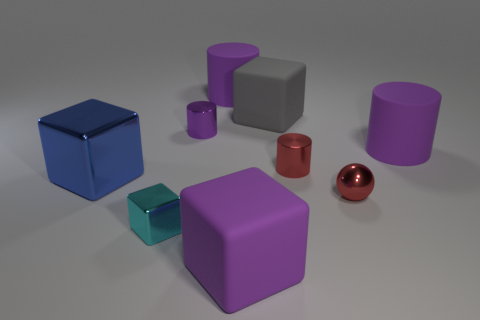What is the material of the large purple cylinder left of the large matte thing in front of the blue metal block?
Your response must be concise. Rubber. There is a matte cylinder that is behind the large matte block that is behind the big cylinder that is right of the tiny ball; what size is it?
Your answer should be very brief. Large. How many other objects are the same shape as the small purple thing?
Ensure brevity in your answer.  3. Is the color of the large matte cylinder that is behind the small purple cylinder the same as the large cylinder to the right of the red metal sphere?
Your answer should be very brief. Yes. The cylinder that is the same size as the purple metallic thing is what color?
Make the answer very short. Red. Are there any blocks that have the same color as the large metallic object?
Your answer should be very brief. No. There is a metallic cube that is behind the red sphere; does it have the same size as the tiny red cylinder?
Keep it short and to the point. No. Is the number of tiny balls that are on the left side of the small red ball the same as the number of big gray matte cubes?
Ensure brevity in your answer.  No. What number of things are either matte blocks left of the large gray matte block or purple matte cylinders?
Offer a terse response. 3. There is a thing that is on the left side of the purple shiny cylinder and in front of the large shiny block; what shape is it?
Your answer should be compact. Cube. 